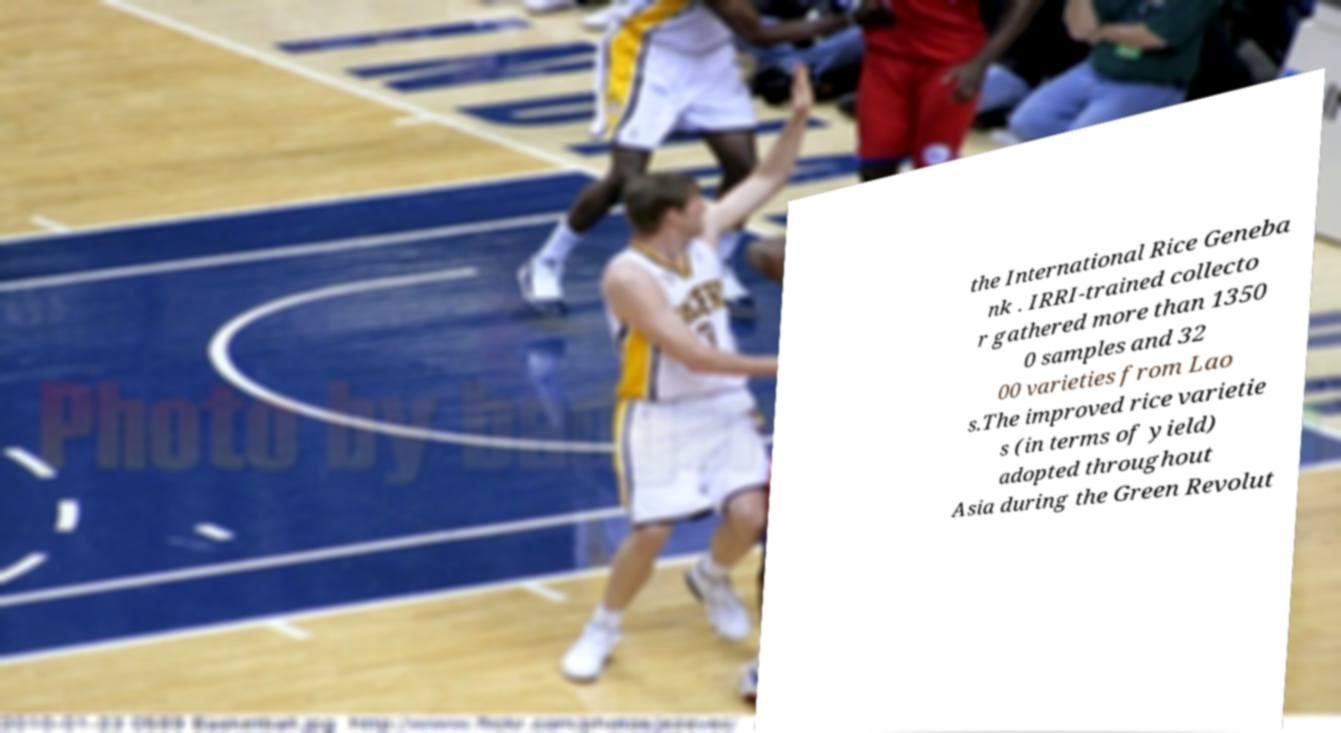Please read and relay the text visible in this image. What does it say? the International Rice Geneba nk . IRRI-trained collecto r gathered more than 1350 0 samples and 32 00 varieties from Lao s.The improved rice varietie s (in terms of yield) adopted throughout Asia during the Green Revolut 